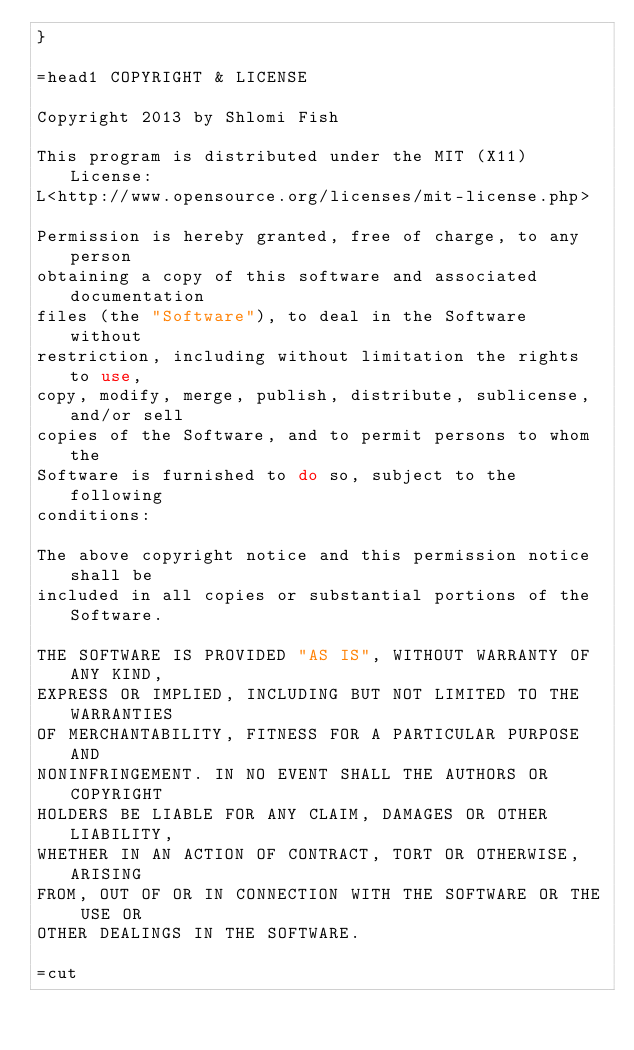<code> <loc_0><loc_0><loc_500><loc_500><_Perl_>}

=head1 COPYRIGHT & LICENSE

Copyright 2013 by Shlomi Fish

This program is distributed under the MIT (X11) License:
L<http://www.opensource.org/licenses/mit-license.php>

Permission is hereby granted, free of charge, to any person
obtaining a copy of this software and associated documentation
files (the "Software"), to deal in the Software without
restriction, including without limitation the rights to use,
copy, modify, merge, publish, distribute, sublicense, and/or sell
copies of the Software, and to permit persons to whom the
Software is furnished to do so, subject to the following
conditions:

The above copyright notice and this permission notice shall be
included in all copies or substantial portions of the Software.

THE SOFTWARE IS PROVIDED "AS IS", WITHOUT WARRANTY OF ANY KIND,
EXPRESS OR IMPLIED, INCLUDING BUT NOT LIMITED TO THE WARRANTIES
OF MERCHANTABILITY, FITNESS FOR A PARTICULAR PURPOSE AND
NONINFRINGEMENT. IN NO EVENT SHALL THE AUTHORS OR COPYRIGHT
HOLDERS BE LIABLE FOR ANY CLAIM, DAMAGES OR OTHER LIABILITY,
WHETHER IN AN ACTION OF CONTRACT, TORT OR OTHERWISE, ARISING
FROM, OUT OF OR IN CONNECTION WITH THE SOFTWARE OR THE USE OR
OTHER DEALINGS IN THE SOFTWARE.

=cut
</code> 